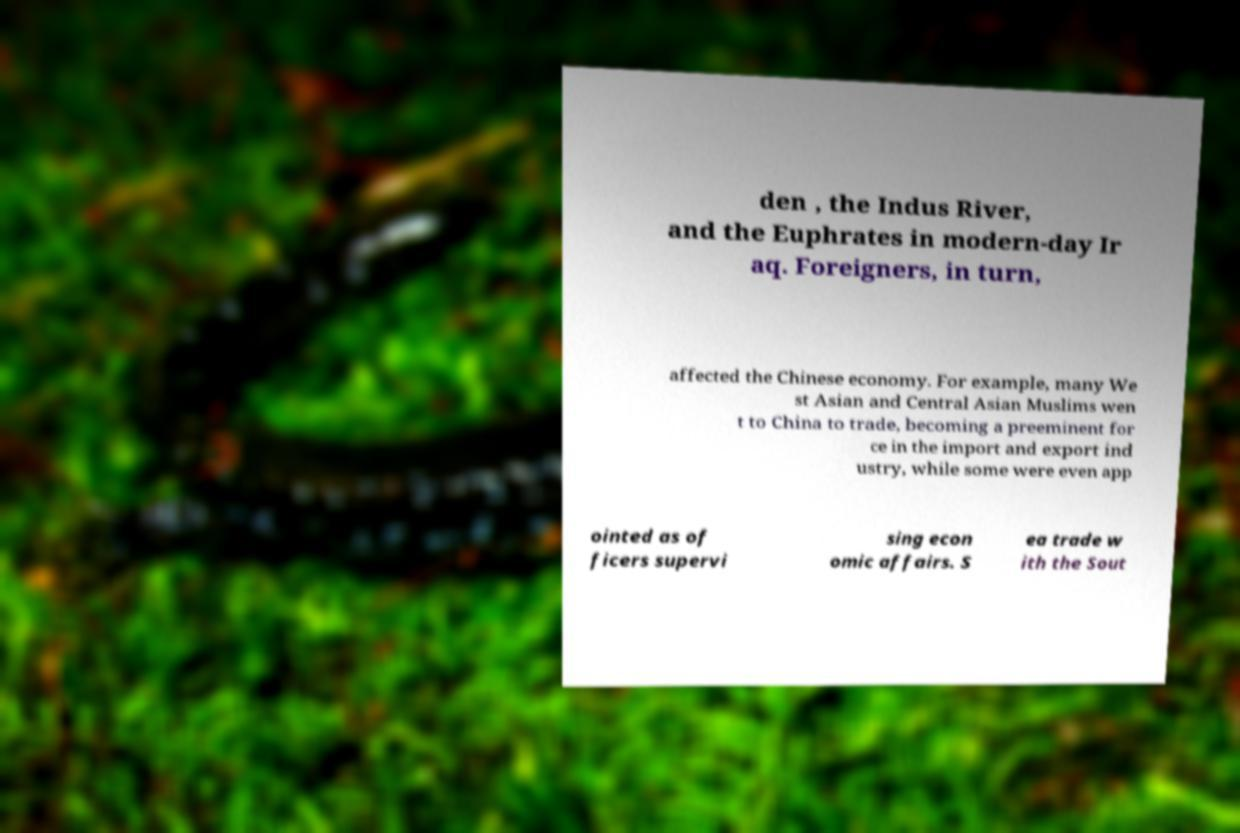I need the written content from this picture converted into text. Can you do that? den , the Indus River, and the Euphrates in modern-day Ir aq. Foreigners, in turn, affected the Chinese economy. For example, many We st Asian and Central Asian Muslims wen t to China to trade, becoming a preeminent for ce in the import and export ind ustry, while some were even app ointed as of ficers supervi sing econ omic affairs. S ea trade w ith the Sout 